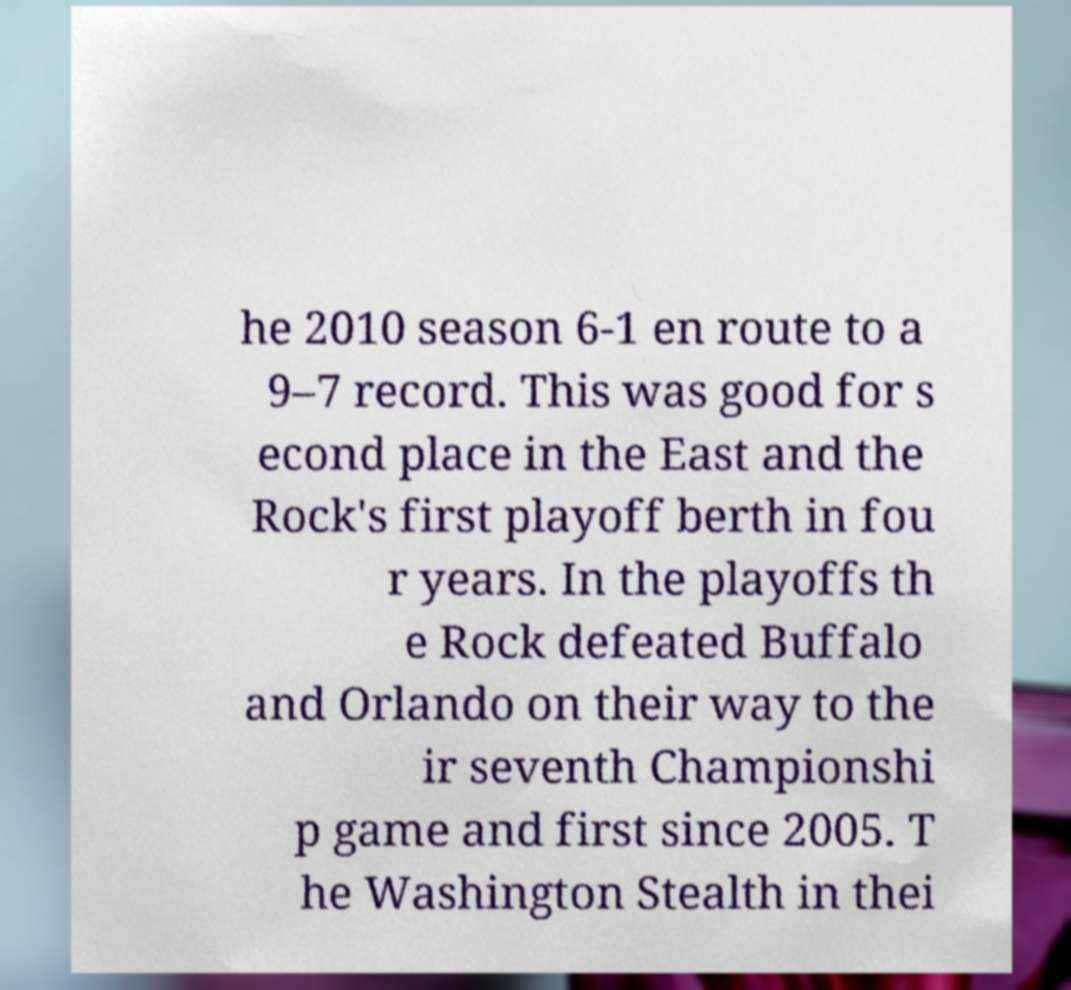There's text embedded in this image that I need extracted. Can you transcribe it verbatim? he 2010 season 6-1 en route to a 9–7 record. This was good for s econd place in the East and the Rock's first playoff berth in fou r years. In the playoffs th e Rock defeated Buffalo and Orlando on their way to the ir seventh Championshi p game and first since 2005. T he Washington Stealth in thei 